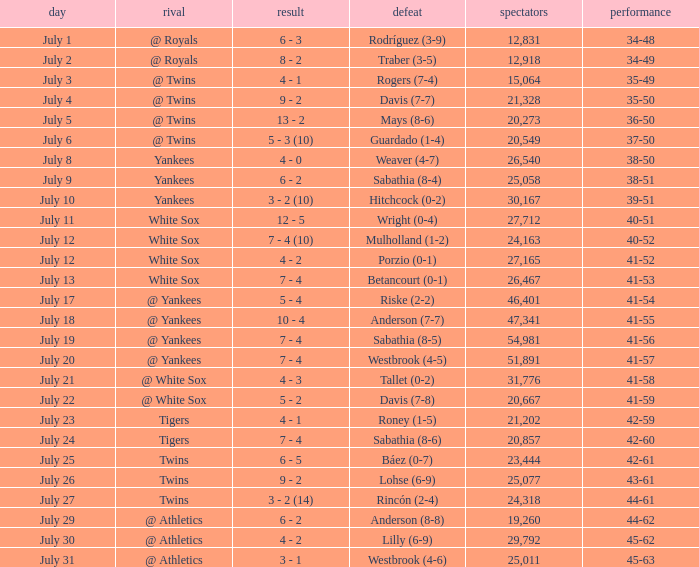Which Record has an Opponent of twins, and a Date of july 25? 42-61. 